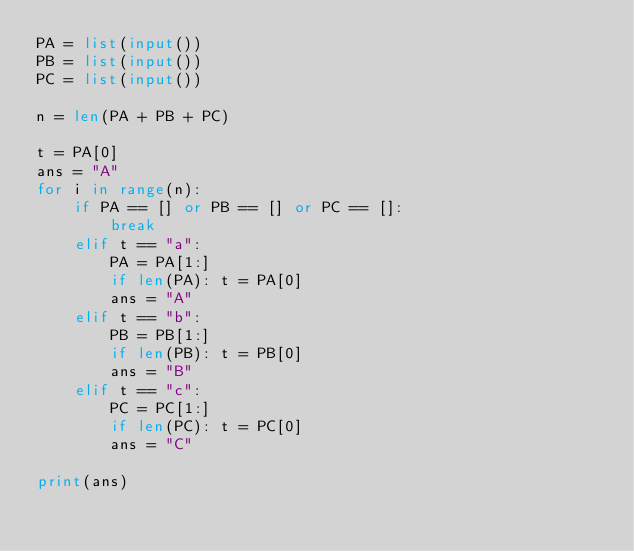Convert code to text. <code><loc_0><loc_0><loc_500><loc_500><_Python_>PA = list(input())
PB = list(input())
PC = list(input())

n = len(PA + PB + PC)

t = PA[0]
ans = "A" 
for i in range(n):
    if PA == [] or PB == [] or PC == []:
        break
    elif t == "a":
        PA = PA[1:]
        if len(PA): t = PA[0]
        ans = "A"
    elif t == "b":
        PB = PB[1:]
        if len(PB): t = PB[0]
        ans = "B"
    elif t == "c":
        PC = PC[1:]
        if len(PC): t = PC[0]
        ans = "C"

print(ans)</code> 